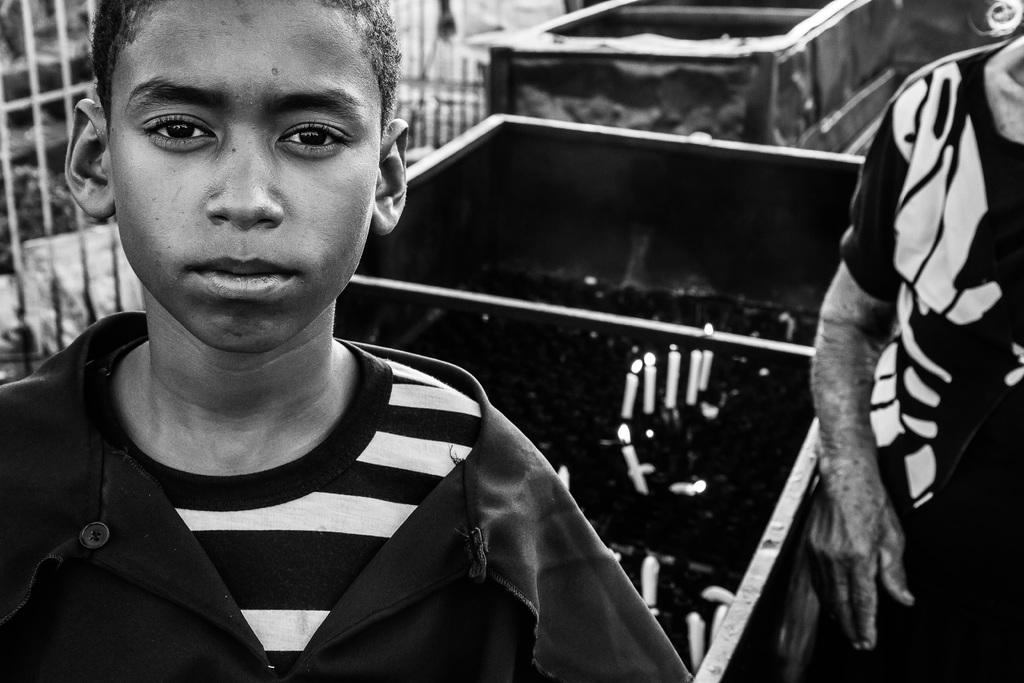What is the color scheme of the image? The image is black and white. How many people are present in the image? There are two people standing in the image. What objects with flames can be seen in the image? There are candles with flames in the image. What type of vehicles are visible in the image? There are trucks in the image. Can you describe the background of the image? There might be a fence in the background of the image. How many loaves of bread are being carried by the girls in the image? There are no girls present in the image, and therefore no loaves of bread can be observed. What type of territory is depicted in the image? The image does not depict any specific territory; it is a black and white image with people, candles, trucks, and possibly a fence in the background. 